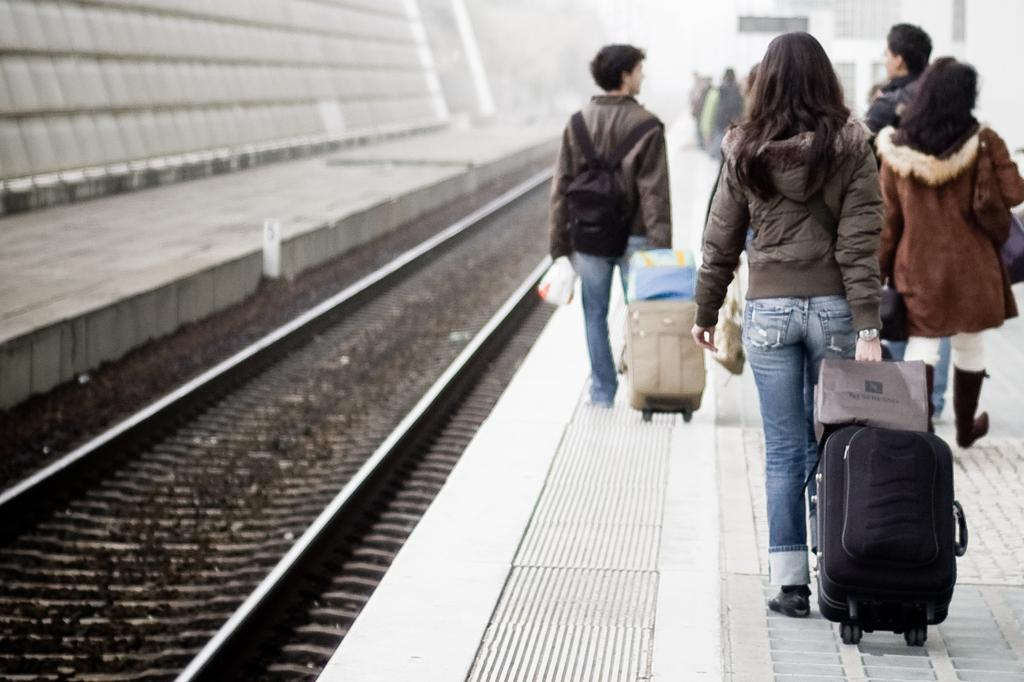What is happening with the group of people in the image? The people are walking in the image. What are some of the people holding in their hands? Some people are holding baggage in their hands. What can be seen on the ground in the image? There are tracks visible in the image. Can you see a frog rolling on the tracks in the image? No, there is no frog or rolling action visible in the image. 